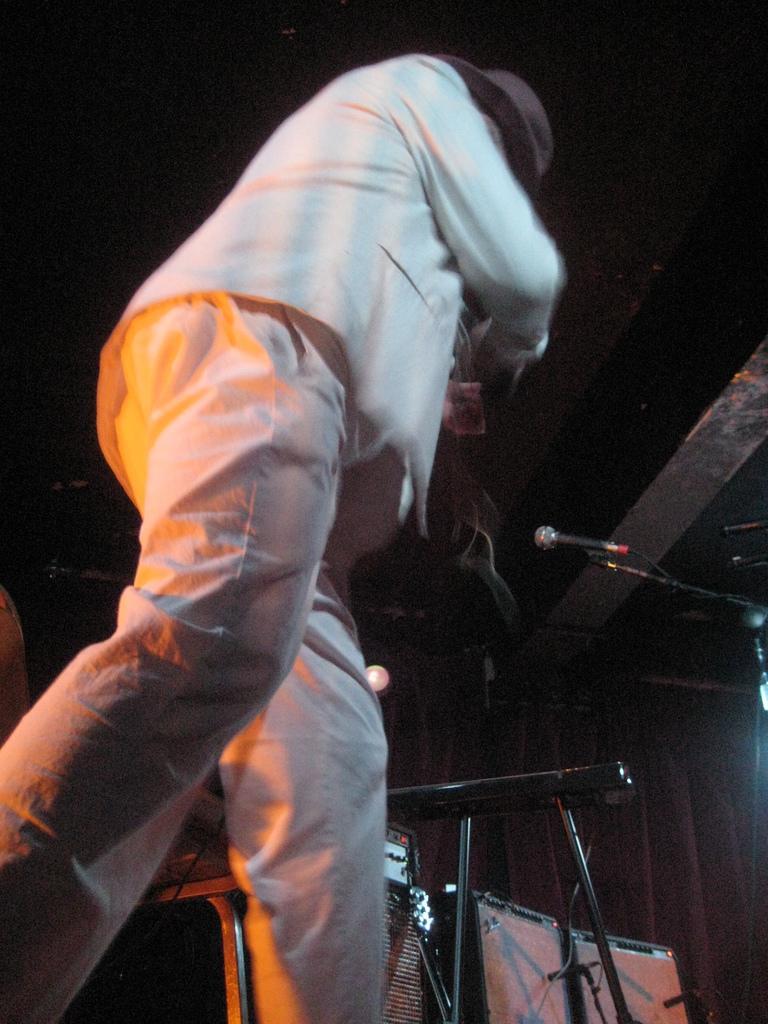Could you give a brief overview of what you see in this image? In the image a man is standing and holding a musical instrument. Behind him there are some microphones and musical devices. 